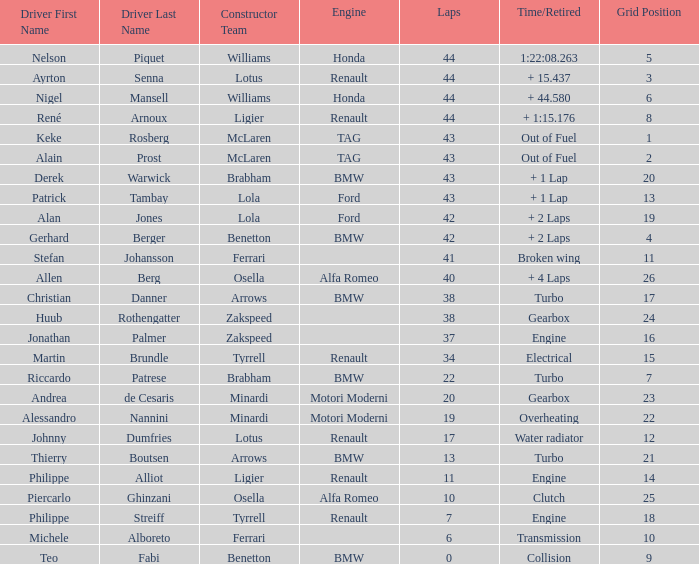Tell me the time/retired for Laps of 42 and Grids of 4 + 2 Laps. 